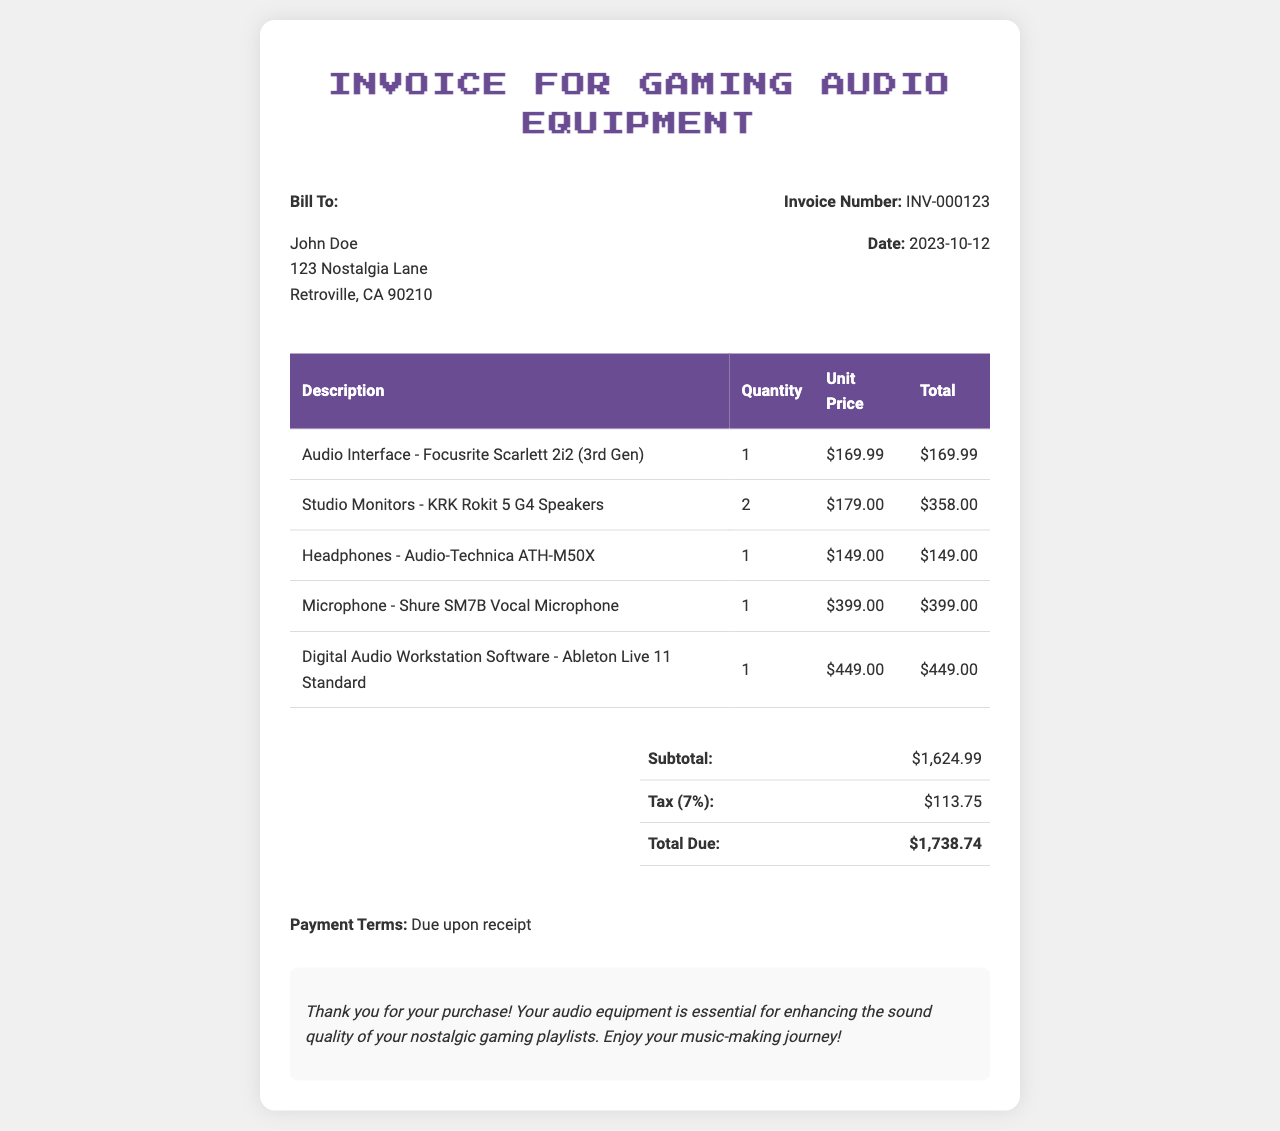What is the invoice number? The invoice number is specified in the document header, labeled as "Invoice Number."
Answer: INV-000123 What is the total due amount? The total due amount is calculated at the bottom of the invoice, listed under "Total Due."
Answer: $1,738.74 Who is the bill to? The recipient information is shown at the top left of the invoice, under "Bill To."
Answer: John Doe What is the date of the invoice? The date is provided in the header section of the invoice, labeled as "Date."
Answer: 2023-10-12 How many studio monitors were purchased? The quantity of studio monitors is listed in the table, corresponding to the row for "Studio Monitors."
Answer: 2 What is the subtotal before tax? The subtotal amount is summarized before the tax calculation at the bottom of the invoice.
Answer: $1,624.99 Which microphone is listed in the invoice? The microphone purchased is specified in the table along with its description.
Answer: Shure SM7B Vocal Microphone What is the tax percentage applied? The tax percentage is mentioned in the total section of the invoice, specifically indicated next to "Tax."
Answer: 7% What is mentioned in the notes section? The notes section contains additional information directed to the buyer regarding their purchase and appreciation.
Answer: Thank you for your purchase! Your audio equipment is essential for enhancing the sound quality of your nostalgic gaming playlists. Enjoy your music-making journey! 